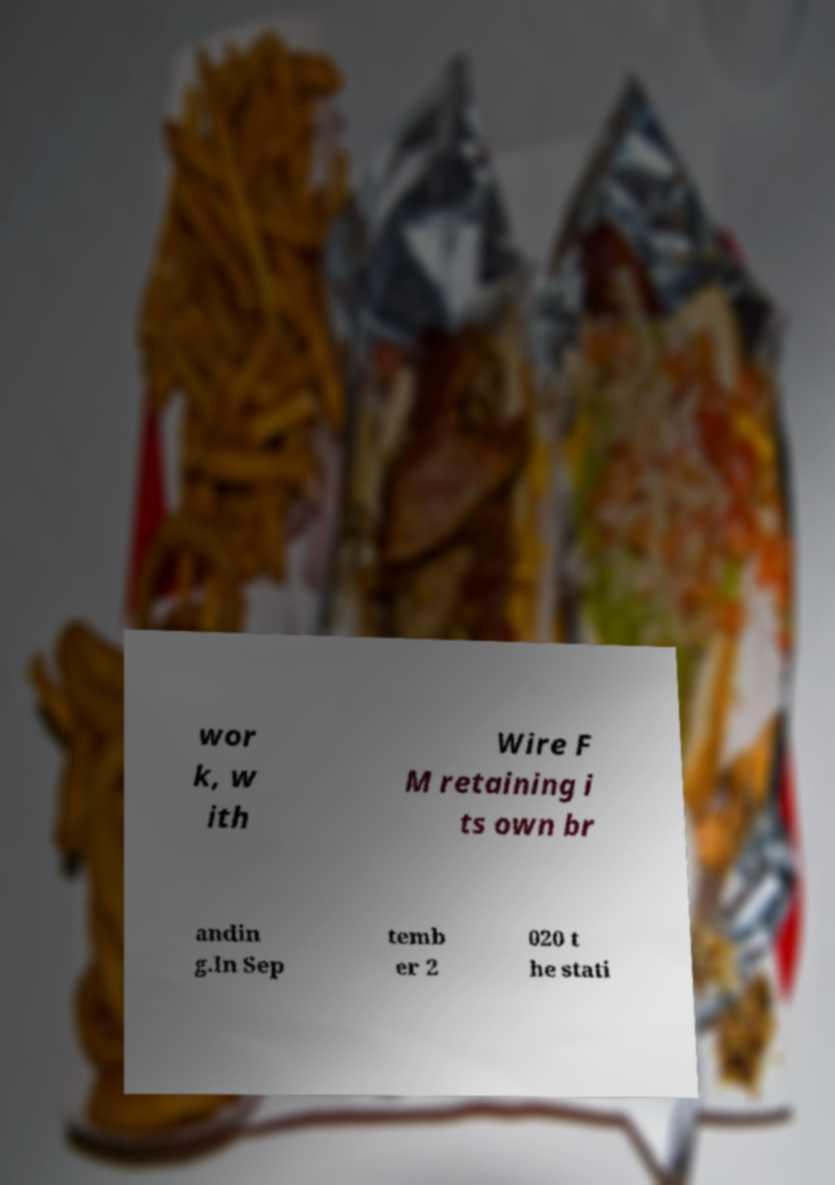Can you accurately transcribe the text from the provided image for me? wor k, w ith Wire F M retaining i ts own br andin g.In Sep temb er 2 020 t he stati 